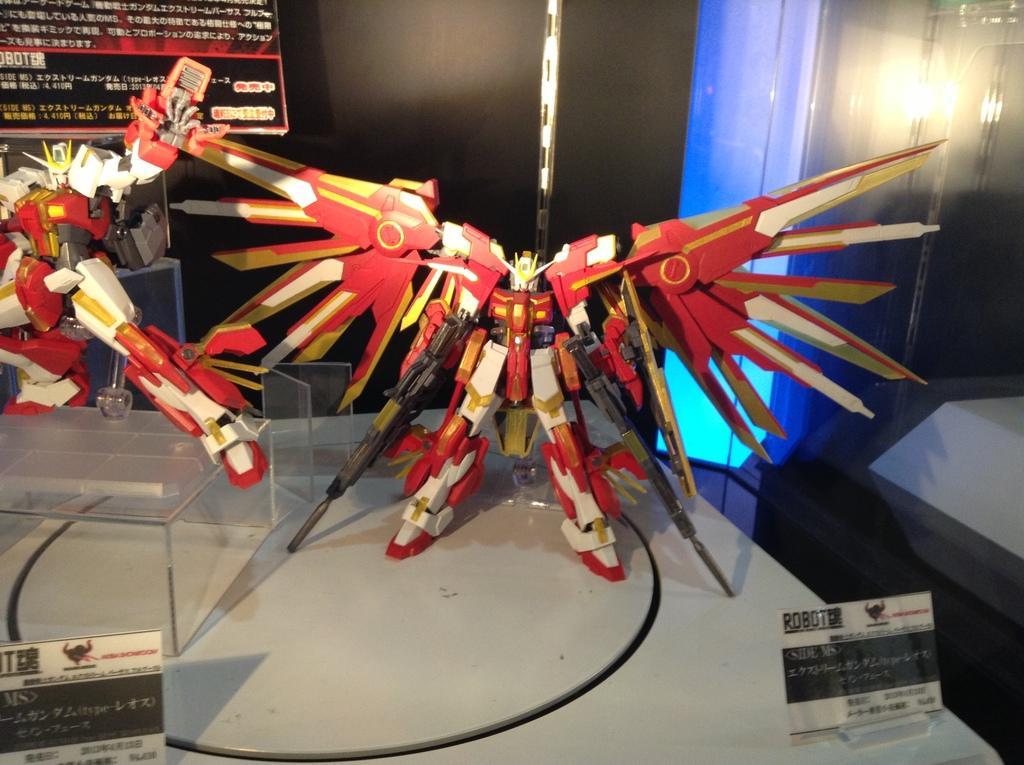In one or two sentences, can you explain what this image depicts? In this picture I can see there are two robots placed on the table and it is in red and white color. There is a small board placed on the table and in the backdrop there is another board and a wall. 